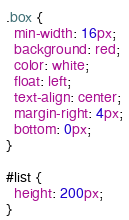<code> <loc_0><loc_0><loc_500><loc_500><_CSS_>.box {
  min-width: 16px;
  background: red;
  color: white;
  float: left;
  text-align: center;
  margin-right: 4px;
  bottom: 0px;
}

#list {
  height: 200px;
}
</code> 